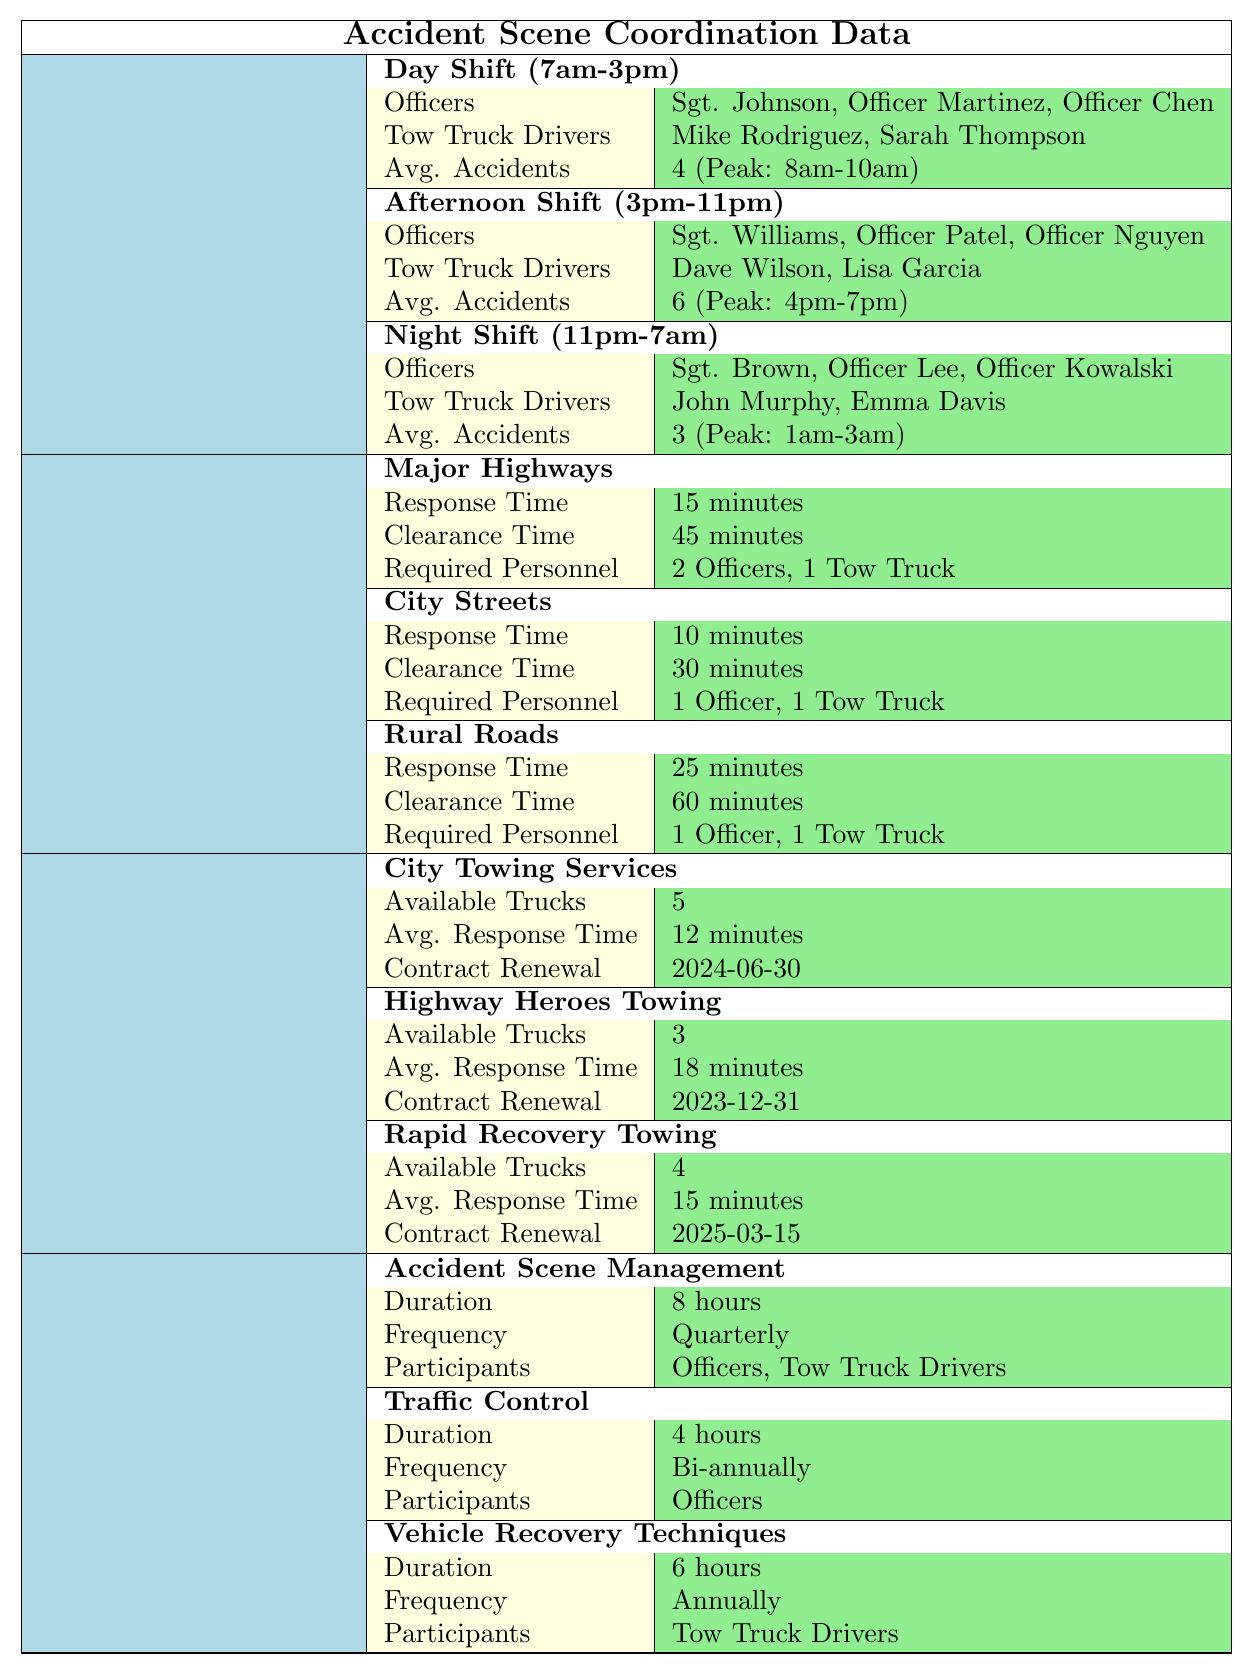What are the names of the officers on the day shift? The table lists the officers assigned to the day shift (7am-3pm) as Sgt. Johnson, Officer Martinez, and Officer Chen.
Answer: Sgt. Johnson, Officer Martinez, Officer Chen How long is the clearance time for accidents on rural roads? According to the table, the clearance time for accidents on rural roads is specified as 60 minutes.
Answer: 60 minutes What is the average number of accidents during the afternoon shift? The table indicates that the average number of accidents during the afternoon shift (3pm-11pm) is 6.
Answer: 6 True or False: Mike Rodriguez is a Tow Truck Driver working the night shift. The table shows that Mike Rodriguez is a Tow Truck Driver on the day shift, not the night shift, so this statement is False.
Answer: False Which shift has the highest average accidents per shift? When comparing the average accidents reported for each shift, the afternoon shift has the highest average of 6 accidents. The day shift has 4, and the night shift has 3.
Answer: Afternoon shift How many total vehicles are required to clear an accident on Major Highways? The table indicates that Major Highways require 2 Officers and 1 Tow Truck, totaling 3 vehicles.
Answer: 3 vehicles What is the response time for clearing accidents on City Streets in comparison to Rural Roads? The response time for City Streets is 10 minutes, while for Rural Roads it is 25 minutes. Therefore, City Streets have a quicker response time, which is 15 minutes shorter than Rural Roads.
Answer: 15 minutes shorter What is the frequency of the Accident Scene Management training program? The table states that the Accident Scene Management training program is conducted quarterly.
Answer: Quarterly If we sum up the average accidents per shift for all shifts, what is the total? The average accidents are 4 for the day shift, 6 for the afternoon shift, and 3 for the night shift. Summing these gives 4 + 6 + 3 = 13.
Answer: 13 Which Tow Truck Company has the shortest average response time? The table compares the average response times: City Towing Services has 12 minutes, Rapid Recovery Towing has 15 minutes, and Highway Heroes Towing has 18 minutes. City Towing Services has the shortest average response time.
Answer: City Towing Services 